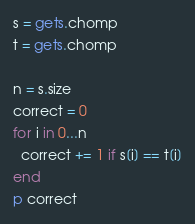Convert code to text. <code><loc_0><loc_0><loc_500><loc_500><_Ruby_>s = gets.chomp
t = gets.chomp

n = s.size
correct = 0
for i in 0...n
  correct += 1 if s[i] == t[i]
end
p correct</code> 